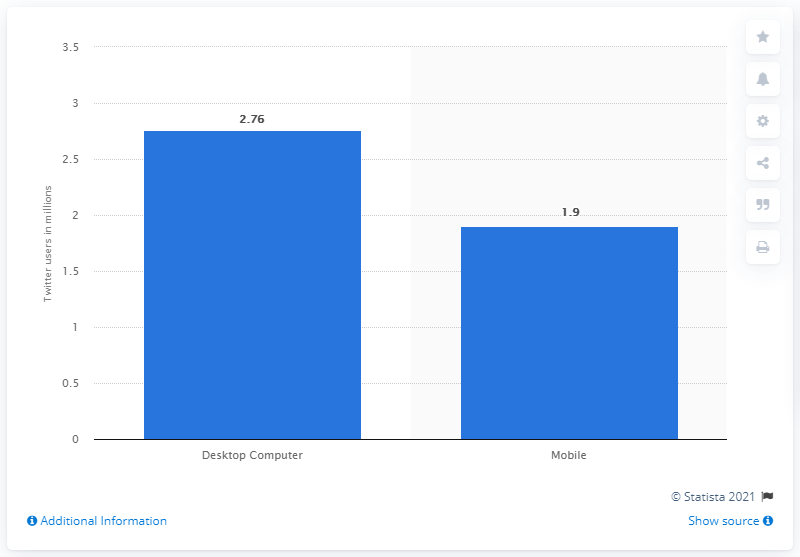Draw attention to some important aspects in this diagram. In the past month, an estimated 1.9 million users visited Twitter through their personal computers. 